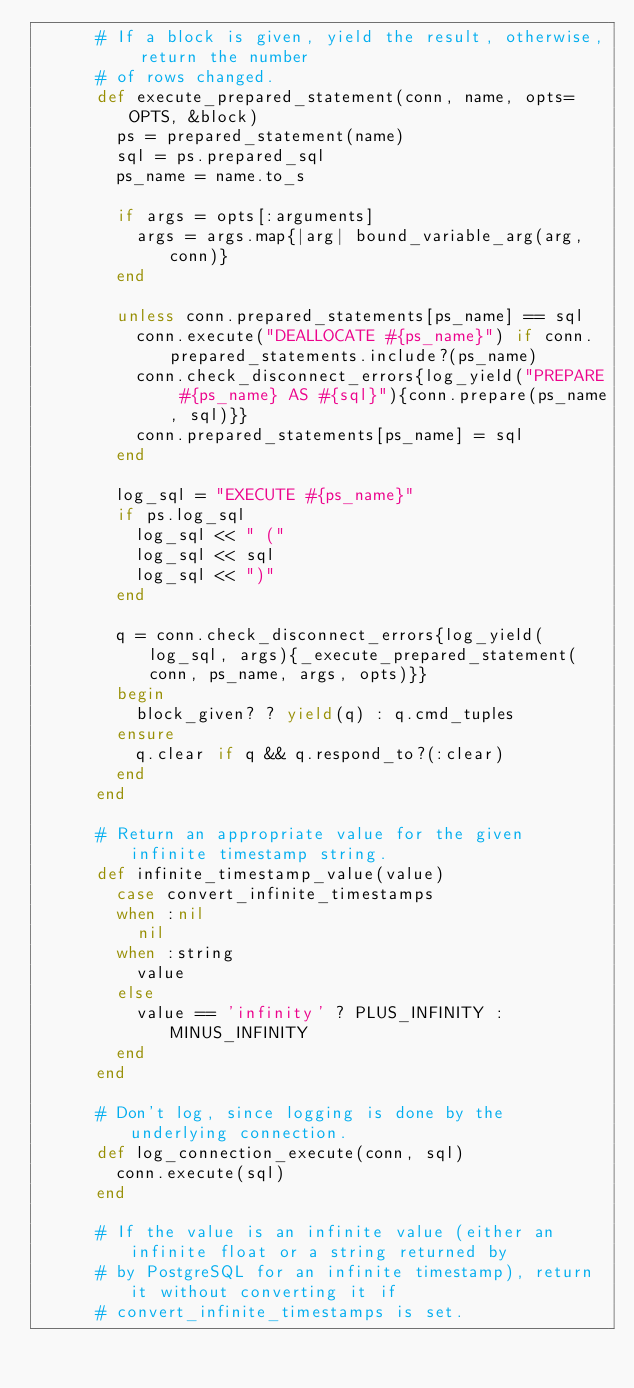Convert code to text. <code><loc_0><loc_0><loc_500><loc_500><_Ruby_>      # If a block is given, yield the result, otherwise, return the number
      # of rows changed.
      def execute_prepared_statement(conn, name, opts=OPTS, &block)
        ps = prepared_statement(name)
        sql = ps.prepared_sql
        ps_name = name.to_s

        if args = opts[:arguments]
          args = args.map{|arg| bound_variable_arg(arg, conn)}
        end

        unless conn.prepared_statements[ps_name] == sql
          conn.execute("DEALLOCATE #{ps_name}") if conn.prepared_statements.include?(ps_name)
          conn.check_disconnect_errors{log_yield("PREPARE #{ps_name} AS #{sql}"){conn.prepare(ps_name, sql)}}
          conn.prepared_statements[ps_name] = sql
        end

        log_sql = "EXECUTE #{ps_name}"
        if ps.log_sql
          log_sql << " ("
          log_sql << sql
          log_sql << ")"
        end

        q = conn.check_disconnect_errors{log_yield(log_sql, args){_execute_prepared_statement(conn, ps_name, args, opts)}}
        begin
          block_given? ? yield(q) : q.cmd_tuples
        ensure
          q.clear if q && q.respond_to?(:clear)
        end
      end

      # Return an appropriate value for the given infinite timestamp string.
      def infinite_timestamp_value(value)
        case convert_infinite_timestamps
        when :nil
          nil
        when :string
          value
        else
          value == 'infinity' ? PLUS_INFINITY : MINUS_INFINITY
        end
      end
      
      # Don't log, since logging is done by the underlying connection.
      def log_connection_execute(conn, sql)
        conn.execute(sql)
      end

      # If the value is an infinite value (either an infinite float or a string returned by
      # by PostgreSQL for an infinite timestamp), return it without converting it if
      # convert_infinite_timestamps is set.</code> 